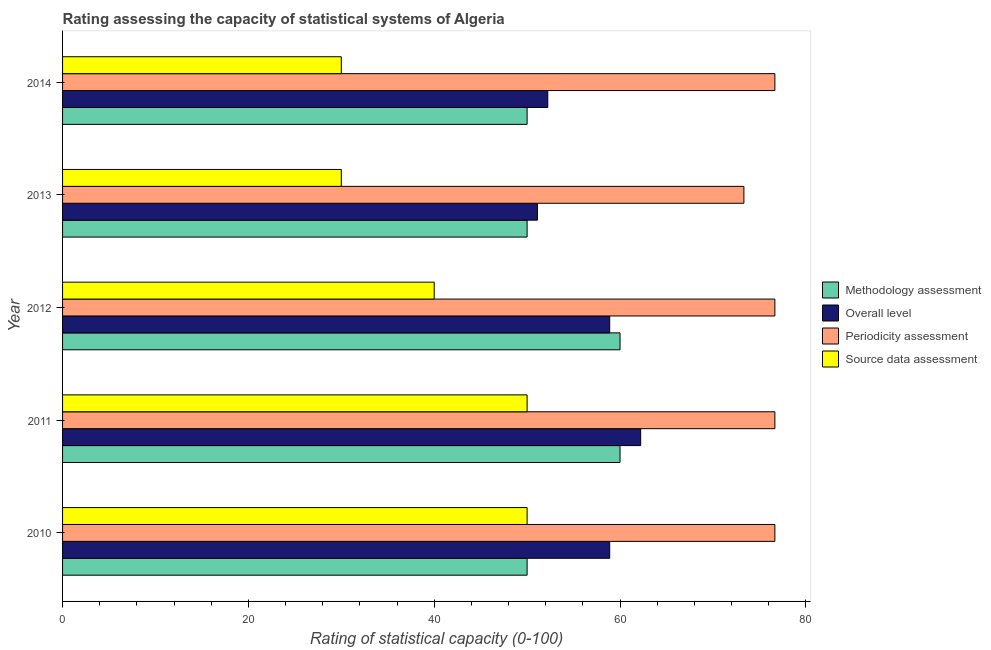How many different coloured bars are there?
Provide a short and direct response. 4. Are the number of bars on each tick of the Y-axis equal?
Offer a terse response. Yes. How many bars are there on the 3rd tick from the bottom?
Your answer should be very brief. 4. In how many cases, is the number of bars for a given year not equal to the number of legend labels?
Give a very brief answer. 0. What is the source data assessment rating in 2010?
Your answer should be compact. 50. Across all years, what is the maximum source data assessment rating?
Ensure brevity in your answer.  50. Across all years, what is the minimum overall level rating?
Provide a short and direct response. 51.11. In which year was the periodicity assessment rating maximum?
Make the answer very short. 2010. In which year was the periodicity assessment rating minimum?
Offer a terse response. 2013. What is the total methodology assessment rating in the graph?
Your response must be concise. 270. What is the difference between the overall level rating in 2010 and that in 2014?
Make the answer very short. 6.67. What is the difference between the overall level rating in 2010 and the source data assessment rating in 2014?
Keep it short and to the point. 28.89. What is the average source data assessment rating per year?
Ensure brevity in your answer.  40. In the year 2010, what is the difference between the methodology assessment rating and source data assessment rating?
Provide a short and direct response. 0. In how many years, is the methodology assessment rating greater than 56 ?
Keep it short and to the point. 2. What is the difference between the highest and the lowest source data assessment rating?
Your answer should be compact. 20. Is it the case that in every year, the sum of the overall level rating and periodicity assessment rating is greater than the sum of source data assessment rating and methodology assessment rating?
Make the answer very short. Yes. What does the 2nd bar from the top in 2010 represents?
Your answer should be compact. Periodicity assessment. What does the 2nd bar from the bottom in 2013 represents?
Ensure brevity in your answer.  Overall level. Is it the case that in every year, the sum of the methodology assessment rating and overall level rating is greater than the periodicity assessment rating?
Your answer should be very brief. Yes. How many bars are there?
Provide a short and direct response. 20. What is the difference between two consecutive major ticks on the X-axis?
Your answer should be compact. 20. Does the graph contain any zero values?
Provide a short and direct response. No. Does the graph contain grids?
Provide a succinct answer. No. How many legend labels are there?
Give a very brief answer. 4. What is the title of the graph?
Your answer should be very brief. Rating assessing the capacity of statistical systems of Algeria. Does "UNRWA" appear as one of the legend labels in the graph?
Make the answer very short. No. What is the label or title of the X-axis?
Make the answer very short. Rating of statistical capacity (0-100). What is the Rating of statistical capacity (0-100) in Overall level in 2010?
Ensure brevity in your answer.  58.89. What is the Rating of statistical capacity (0-100) in Periodicity assessment in 2010?
Give a very brief answer. 76.67. What is the Rating of statistical capacity (0-100) of Methodology assessment in 2011?
Keep it short and to the point. 60. What is the Rating of statistical capacity (0-100) in Overall level in 2011?
Ensure brevity in your answer.  62.22. What is the Rating of statistical capacity (0-100) of Periodicity assessment in 2011?
Offer a very short reply. 76.67. What is the Rating of statistical capacity (0-100) in Source data assessment in 2011?
Your response must be concise. 50. What is the Rating of statistical capacity (0-100) of Overall level in 2012?
Offer a very short reply. 58.89. What is the Rating of statistical capacity (0-100) in Periodicity assessment in 2012?
Your response must be concise. 76.67. What is the Rating of statistical capacity (0-100) of Source data assessment in 2012?
Your response must be concise. 40. What is the Rating of statistical capacity (0-100) in Overall level in 2013?
Your response must be concise. 51.11. What is the Rating of statistical capacity (0-100) of Periodicity assessment in 2013?
Provide a short and direct response. 73.33. What is the Rating of statistical capacity (0-100) in Overall level in 2014?
Provide a succinct answer. 52.22. What is the Rating of statistical capacity (0-100) in Periodicity assessment in 2014?
Provide a succinct answer. 76.67. Across all years, what is the maximum Rating of statistical capacity (0-100) in Methodology assessment?
Your answer should be very brief. 60. Across all years, what is the maximum Rating of statistical capacity (0-100) of Overall level?
Ensure brevity in your answer.  62.22. Across all years, what is the maximum Rating of statistical capacity (0-100) in Periodicity assessment?
Make the answer very short. 76.67. Across all years, what is the minimum Rating of statistical capacity (0-100) of Overall level?
Ensure brevity in your answer.  51.11. Across all years, what is the minimum Rating of statistical capacity (0-100) of Periodicity assessment?
Your answer should be very brief. 73.33. Across all years, what is the minimum Rating of statistical capacity (0-100) of Source data assessment?
Provide a succinct answer. 30. What is the total Rating of statistical capacity (0-100) of Methodology assessment in the graph?
Give a very brief answer. 270. What is the total Rating of statistical capacity (0-100) in Overall level in the graph?
Keep it short and to the point. 283.33. What is the total Rating of statistical capacity (0-100) of Periodicity assessment in the graph?
Provide a succinct answer. 380. What is the difference between the Rating of statistical capacity (0-100) in Methodology assessment in 2010 and that in 2011?
Keep it short and to the point. -10. What is the difference between the Rating of statistical capacity (0-100) of Overall level in 2010 and that in 2012?
Provide a succinct answer. 0. What is the difference between the Rating of statistical capacity (0-100) in Periodicity assessment in 2010 and that in 2012?
Keep it short and to the point. 0. What is the difference between the Rating of statistical capacity (0-100) of Methodology assessment in 2010 and that in 2013?
Your answer should be very brief. 0. What is the difference between the Rating of statistical capacity (0-100) of Overall level in 2010 and that in 2013?
Provide a short and direct response. 7.78. What is the difference between the Rating of statistical capacity (0-100) of Periodicity assessment in 2010 and that in 2013?
Your answer should be compact. 3.33. What is the difference between the Rating of statistical capacity (0-100) of Source data assessment in 2010 and that in 2013?
Provide a short and direct response. 20. What is the difference between the Rating of statistical capacity (0-100) in Periodicity assessment in 2010 and that in 2014?
Make the answer very short. 0. What is the difference between the Rating of statistical capacity (0-100) of Source data assessment in 2010 and that in 2014?
Your answer should be compact. 20. What is the difference between the Rating of statistical capacity (0-100) in Overall level in 2011 and that in 2012?
Offer a very short reply. 3.33. What is the difference between the Rating of statistical capacity (0-100) of Periodicity assessment in 2011 and that in 2012?
Your answer should be compact. 0. What is the difference between the Rating of statistical capacity (0-100) in Overall level in 2011 and that in 2013?
Your response must be concise. 11.11. What is the difference between the Rating of statistical capacity (0-100) of Periodicity assessment in 2011 and that in 2014?
Offer a very short reply. 0. What is the difference between the Rating of statistical capacity (0-100) of Methodology assessment in 2012 and that in 2013?
Offer a terse response. 10. What is the difference between the Rating of statistical capacity (0-100) of Overall level in 2012 and that in 2013?
Make the answer very short. 7.78. What is the difference between the Rating of statistical capacity (0-100) in Overall level in 2012 and that in 2014?
Your answer should be compact. 6.67. What is the difference between the Rating of statistical capacity (0-100) in Periodicity assessment in 2012 and that in 2014?
Provide a short and direct response. 0. What is the difference between the Rating of statistical capacity (0-100) of Overall level in 2013 and that in 2014?
Provide a short and direct response. -1.11. What is the difference between the Rating of statistical capacity (0-100) in Methodology assessment in 2010 and the Rating of statistical capacity (0-100) in Overall level in 2011?
Your answer should be compact. -12.22. What is the difference between the Rating of statistical capacity (0-100) of Methodology assessment in 2010 and the Rating of statistical capacity (0-100) of Periodicity assessment in 2011?
Provide a succinct answer. -26.67. What is the difference between the Rating of statistical capacity (0-100) of Methodology assessment in 2010 and the Rating of statistical capacity (0-100) of Source data assessment in 2011?
Give a very brief answer. 0. What is the difference between the Rating of statistical capacity (0-100) of Overall level in 2010 and the Rating of statistical capacity (0-100) of Periodicity assessment in 2011?
Offer a terse response. -17.78. What is the difference between the Rating of statistical capacity (0-100) in Overall level in 2010 and the Rating of statistical capacity (0-100) in Source data assessment in 2011?
Offer a terse response. 8.89. What is the difference between the Rating of statistical capacity (0-100) of Periodicity assessment in 2010 and the Rating of statistical capacity (0-100) of Source data assessment in 2011?
Provide a short and direct response. 26.67. What is the difference between the Rating of statistical capacity (0-100) in Methodology assessment in 2010 and the Rating of statistical capacity (0-100) in Overall level in 2012?
Offer a very short reply. -8.89. What is the difference between the Rating of statistical capacity (0-100) in Methodology assessment in 2010 and the Rating of statistical capacity (0-100) in Periodicity assessment in 2012?
Your answer should be compact. -26.67. What is the difference between the Rating of statistical capacity (0-100) in Methodology assessment in 2010 and the Rating of statistical capacity (0-100) in Source data assessment in 2012?
Keep it short and to the point. 10. What is the difference between the Rating of statistical capacity (0-100) of Overall level in 2010 and the Rating of statistical capacity (0-100) of Periodicity assessment in 2012?
Provide a short and direct response. -17.78. What is the difference between the Rating of statistical capacity (0-100) in Overall level in 2010 and the Rating of statistical capacity (0-100) in Source data assessment in 2012?
Keep it short and to the point. 18.89. What is the difference between the Rating of statistical capacity (0-100) in Periodicity assessment in 2010 and the Rating of statistical capacity (0-100) in Source data assessment in 2012?
Your answer should be very brief. 36.67. What is the difference between the Rating of statistical capacity (0-100) in Methodology assessment in 2010 and the Rating of statistical capacity (0-100) in Overall level in 2013?
Your response must be concise. -1.11. What is the difference between the Rating of statistical capacity (0-100) in Methodology assessment in 2010 and the Rating of statistical capacity (0-100) in Periodicity assessment in 2013?
Make the answer very short. -23.33. What is the difference between the Rating of statistical capacity (0-100) of Methodology assessment in 2010 and the Rating of statistical capacity (0-100) of Source data assessment in 2013?
Your answer should be compact. 20. What is the difference between the Rating of statistical capacity (0-100) in Overall level in 2010 and the Rating of statistical capacity (0-100) in Periodicity assessment in 2013?
Your response must be concise. -14.44. What is the difference between the Rating of statistical capacity (0-100) in Overall level in 2010 and the Rating of statistical capacity (0-100) in Source data assessment in 2013?
Provide a short and direct response. 28.89. What is the difference between the Rating of statistical capacity (0-100) of Periodicity assessment in 2010 and the Rating of statistical capacity (0-100) of Source data assessment in 2013?
Provide a short and direct response. 46.67. What is the difference between the Rating of statistical capacity (0-100) of Methodology assessment in 2010 and the Rating of statistical capacity (0-100) of Overall level in 2014?
Your answer should be very brief. -2.22. What is the difference between the Rating of statistical capacity (0-100) of Methodology assessment in 2010 and the Rating of statistical capacity (0-100) of Periodicity assessment in 2014?
Offer a terse response. -26.67. What is the difference between the Rating of statistical capacity (0-100) of Methodology assessment in 2010 and the Rating of statistical capacity (0-100) of Source data assessment in 2014?
Provide a succinct answer. 20. What is the difference between the Rating of statistical capacity (0-100) in Overall level in 2010 and the Rating of statistical capacity (0-100) in Periodicity assessment in 2014?
Give a very brief answer. -17.78. What is the difference between the Rating of statistical capacity (0-100) of Overall level in 2010 and the Rating of statistical capacity (0-100) of Source data assessment in 2014?
Your answer should be very brief. 28.89. What is the difference between the Rating of statistical capacity (0-100) of Periodicity assessment in 2010 and the Rating of statistical capacity (0-100) of Source data assessment in 2014?
Offer a terse response. 46.67. What is the difference between the Rating of statistical capacity (0-100) of Methodology assessment in 2011 and the Rating of statistical capacity (0-100) of Overall level in 2012?
Make the answer very short. 1.11. What is the difference between the Rating of statistical capacity (0-100) of Methodology assessment in 2011 and the Rating of statistical capacity (0-100) of Periodicity assessment in 2012?
Give a very brief answer. -16.67. What is the difference between the Rating of statistical capacity (0-100) in Methodology assessment in 2011 and the Rating of statistical capacity (0-100) in Source data assessment in 2012?
Ensure brevity in your answer.  20. What is the difference between the Rating of statistical capacity (0-100) in Overall level in 2011 and the Rating of statistical capacity (0-100) in Periodicity assessment in 2012?
Provide a succinct answer. -14.44. What is the difference between the Rating of statistical capacity (0-100) of Overall level in 2011 and the Rating of statistical capacity (0-100) of Source data assessment in 2012?
Your answer should be very brief. 22.22. What is the difference between the Rating of statistical capacity (0-100) of Periodicity assessment in 2011 and the Rating of statistical capacity (0-100) of Source data assessment in 2012?
Give a very brief answer. 36.67. What is the difference between the Rating of statistical capacity (0-100) of Methodology assessment in 2011 and the Rating of statistical capacity (0-100) of Overall level in 2013?
Your response must be concise. 8.89. What is the difference between the Rating of statistical capacity (0-100) of Methodology assessment in 2011 and the Rating of statistical capacity (0-100) of Periodicity assessment in 2013?
Offer a terse response. -13.33. What is the difference between the Rating of statistical capacity (0-100) of Methodology assessment in 2011 and the Rating of statistical capacity (0-100) of Source data assessment in 2013?
Ensure brevity in your answer.  30. What is the difference between the Rating of statistical capacity (0-100) of Overall level in 2011 and the Rating of statistical capacity (0-100) of Periodicity assessment in 2013?
Make the answer very short. -11.11. What is the difference between the Rating of statistical capacity (0-100) of Overall level in 2011 and the Rating of statistical capacity (0-100) of Source data assessment in 2013?
Ensure brevity in your answer.  32.22. What is the difference between the Rating of statistical capacity (0-100) of Periodicity assessment in 2011 and the Rating of statistical capacity (0-100) of Source data assessment in 2013?
Your response must be concise. 46.67. What is the difference between the Rating of statistical capacity (0-100) in Methodology assessment in 2011 and the Rating of statistical capacity (0-100) in Overall level in 2014?
Offer a very short reply. 7.78. What is the difference between the Rating of statistical capacity (0-100) of Methodology assessment in 2011 and the Rating of statistical capacity (0-100) of Periodicity assessment in 2014?
Provide a short and direct response. -16.67. What is the difference between the Rating of statistical capacity (0-100) in Methodology assessment in 2011 and the Rating of statistical capacity (0-100) in Source data assessment in 2014?
Offer a very short reply. 30. What is the difference between the Rating of statistical capacity (0-100) of Overall level in 2011 and the Rating of statistical capacity (0-100) of Periodicity assessment in 2014?
Ensure brevity in your answer.  -14.44. What is the difference between the Rating of statistical capacity (0-100) of Overall level in 2011 and the Rating of statistical capacity (0-100) of Source data assessment in 2014?
Your answer should be compact. 32.22. What is the difference between the Rating of statistical capacity (0-100) in Periodicity assessment in 2011 and the Rating of statistical capacity (0-100) in Source data assessment in 2014?
Your response must be concise. 46.67. What is the difference between the Rating of statistical capacity (0-100) of Methodology assessment in 2012 and the Rating of statistical capacity (0-100) of Overall level in 2013?
Provide a short and direct response. 8.89. What is the difference between the Rating of statistical capacity (0-100) of Methodology assessment in 2012 and the Rating of statistical capacity (0-100) of Periodicity assessment in 2013?
Provide a short and direct response. -13.33. What is the difference between the Rating of statistical capacity (0-100) of Overall level in 2012 and the Rating of statistical capacity (0-100) of Periodicity assessment in 2013?
Provide a succinct answer. -14.44. What is the difference between the Rating of statistical capacity (0-100) in Overall level in 2012 and the Rating of statistical capacity (0-100) in Source data assessment in 2013?
Provide a short and direct response. 28.89. What is the difference between the Rating of statistical capacity (0-100) in Periodicity assessment in 2012 and the Rating of statistical capacity (0-100) in Source data assessment in 2013?
Make the answer very short. 46.67. What is the difference between the Rating of statistical capacity (0-100) of Methodology assessment in 2012 and the Rating of statistical capacity (0-100) of Overall level in 2014?
Give a very brief answer. 7.78. What is the difference between the Rating of statistical capacity (0-100) in Methodology assessment in 2012 and the Rating of statistical capacity (0-100) in Periodicity assessment in 2014?
Your response must be concise. -16.67. What is the difference between the Rating of statistical capacity (0-100) in Methodology assessment in 2012 and the Rating of statistical capacity (0-100) in Source data assessment in 2014?
Provide a succinct answer. 30. What is the difference between the Rating of statistical capacity (0-100) in Overall level in 2012 and the Rating of statistical capacity (0-100) in Periodicity assessment in 2014?
Your answer should be very brief. -17.78. What is the difference between the Rating of statistical capacity (0-100) of Overall level in 2012 and the Rating of statistical capacity (0-100) of Source data assessment in 2014?
Give a very brief answer. 28.89. What is the difference between the Rating of statistical capacity (0-100) of Periodicity assessment in 2012 and the Rating of statistical capacity (0-100) of Source data assessment in 2014?
Ensure brevity in your answer.  46.67. What is the difference between the Rating of statistical capacity (0-100) of Methodology assessment in 2013 and the Rating of statistical capacity (0-100) of Overall level in 2014?
Your answer should be very brief. -2.22. What is the difference between the Rating of statistical capacity (0-100) of Methodology assessment in 2013 and the Rating of statistical capacity (0-100) of Periodicity assessment in 2014?
Provide a succinct answer. -26.67. What is the difference between the Rating of statistical capacity (0-100) in Overall level in 2013 and the Rating of statistical capacity (0-100) in Periodicity assessment in 2014?
Ensure brevity in your answer.  -25.56. What is the difference between the Rating of statistical capacity (0-100) of Overall level in 2013 and the Rating of statistical capacity (0-100) of Source data assessment in 2014?
Make the answer very short. 21.11. What is the difference between the Rating of statistical capacity (0-100) of Periodicity assessment in 2013 and the Rating of statistical capacity (0-100) of Source data assessment in 2014?
Provide a short and direct response. 43.33. What is the average Rating of statistical capacity (0-100) in Methodology assessment per year?
Your answer should be very brief. 54. What is the average Rating of statistical capacity (0-100) in Overall level per year?
Make the answer very short. 56.67. What is the average Rating of statistical capacity (0-100) in Periodicity assessment per year?
Give a very brief answer. 76. In the year 2010, what is the difference between the Rating of statistical capacity (0-100) in Methodology assessment and Rating of statistical capacity (0-100) in Overall level?
Your answer should be compact. -8.89. In the year 2010, what is the difference between the Rating of statistical capacity (0-100) in Methodology assessment and Rating of statistical capacity (0-100) in Periodicity assessment?
Your answer should be very brief. -26.67. In the year 2010, what is the difference between the Rating of statistical capacity (0-100) of Methodology assessment and Rating of statistical capacity (0-100) of Source data assessment?
Your answer should be very brief. 0. In the year 2010, what is the difference between the Rating of statistical capacity (0-100) of Overall level and Rating of statistical capacity (0-100) of Periodicity assessment?
Keep it short and to the point. -17.78. In the year 2010, what is the difference between the Rating of statistical capacity (0-100) of Overall level and Rating of statistical capacity (0-100) of Source data assessment?
Make the answer very short. 8.89. In the year 2010, what is the difference between the Rating of statistical capacity (0-100) in Periodicity assessment and Rating of statistical capacity (0-100) in Source data assessment?
Provide a succinct answer. 26.67. In the year 2011, what is the difference between the Rating of statistical capacity (0-100) of Methodology assessment and Rating of statistical capacity (0-100) of Overall level?
Ensure brevity in your answer.  -2.22. In the year 2011, what is the difference between the Rating of statistical capacity (0-100) of Methodology assessment and Rating of statistical capacity (0-100) of Periodicity assessment?
Provide a short and direct response. -16.67. In the year 2011, what is the difference between the Rating of statistical capacity (0-100) in Methodology assessment and Rating of statistical capacity (0-100) in Source data assessment?
Your answer should be very brief. 10. In the year 2011, what is the difference between the Rating of statistical capacity (0-100) in Overall level and Rating of statistical capacity (0-100) in Periodicity assessment?
Your response must be concise. -14.44. In the year 2011, what is the difference between the Rating of statistical capacity (0-100) in Overall level and Rating of statistical capacity (0-100) in Source data assessment?
Offer a very short reply. 12.22. In the year 2011, what is the difference between the Rating of statistical capacity (0-100) in Periodicity assessment and Rating of statistical capacity (0-100) in Source data assessment?
Your response must be concise. 26.67. In the year 2012, what is the difference between the Rating of statistical capacity (0-100) of Methodology assessment and Rating of statistical capacity (0-100) of Periodicity assessment?
Ensure brevity in your answer.  -16.67. In the year 2012, what is the difference between the Rating of statistical capacity (0-100) in Overall level and Rating of statistical capacity (0-100) in Periodicity assessment?
Your answer should be very brief. -17.78. In the year 2012, what is the difference between the Rating of statistical capacity (0-100) in Overall level and Rating of statistical capacity (0-100) in Source data assessment?
Give a very brief answer. 18.89. In the year 2012, what is the difference between the Rating of statistical capacity (0-100) in Periodicity assessment and Rating of statistical capacity (0-100) in Source data assessment?
Offer a very short reply. 36.67. In the year 2013, what is the difference between the Rating of statistical capacity (0-100) in Methodology assessment and Rating of statistical capacity (0-100) in Overall level?
Make the answer very short. -1.11. In the year 2013, what is the difference between the Rating of statistical capacity (0-100) of Methodology assessment and Rating of statistical capacity (0-100) of Periodicity assessment?
Provide a short and direct response. -23.33. In the year 2013, what is the difference between the Rating of statistical capacity (0-100) of Overall level and Rating of statistical capacity (0-100) of Periodicity assessment?
Keep it short and to the point. -22.22. In the year 2013, what is the difference between the Rating of statistical capacity (0-100) of Overall level and Rating of statistical capacity (0-100) of Source data assessment?
Offer a terse response. 21.11. In the year 2013, what is the difference between the Rating of statistical capacity (0-100) of Periodicity assessment and Rating of statistical capacity (0-100) of Source data assessment?
Offer a very short reply. 43.33. In the year 2014, what is the difference between the Rating of statistical capacity (0-100) in Methodology assessment and Rating of statistical capacity (0-100) in Overall level?
Give a very brief answer. -2.22. In the year 2014, what is the difference between the Rating of statistical capacity (0-100) in Methodology assessment and Rating of statistical capacity (0-100) in Periodicity assessment?
Ensure brevity in your answer.  -26.67. In the year 2014, what is the difference between the Rating of statistical capacity (0-100) of Overall level and Rating of statistical capacity (0-100) of Periodicity assessment?
Offer a very short reply. -24.44. In the year 2014, what is the difference between the Rating of statistical capacity (0-100) of Overall level and Rating of statistical capacity (0-100) of Source data assessment?
Keep it short and to the point. 22.22. In the year 2014, what is the difference between the Rating of statistical capacity (0-100) of Periodicity assessment and Rating of statistical capacity (0-100) of Source data assessment?
Ensure brevity in your answer.  46.67. What is the ratio of the Rating of statistical capacity (0-100) of Methodology assessment in 2010 to that in 2011?
Provide a succinct answer. 0.83. What is the ratio of the Rating of statistical capacity (0-100) of Overall level in 2010 to that in 2011?
Your response must be concise. 0.95. What is the ratio of the Rating of statistical capacity (0-100) of Source data assessment in 2010 to that in 2011?
Make the answer very short. 1. What is the ratio of the Rating of statistical capacity (0-100) of Overall level in 2010 to that in 2012?
Offer a very short reply. 1. What is the ratio of the Rating of statistical capacity (0-100) of Periodicity assessment in 2010 to that in 2012?
Make the answer very short. 1. What is the ratio of the Rating of statistical capacity (0-100) in Source data assessment in 2010 to that in 2012?
Your answer should be very brief. 1.25. What is the ratio of the Rating of statistical capacity (0-100) of Methodology assessment in 2010 to that in 2013?
Offer a terse response. 1. What is the ratio of the Rating of statistical capacity (0-100) in Overall level in 2010 to that in 2013?
Your answer should be very brief. 1.15. What is the ratio of the Rating of statistical capacity (0-100) in Periodicity assessment in 2010 to that in 2013?
Your response must be concise. 1.05. What is the ratio of the Rating of statistical capacity (0-100) in Methodology assessment in 2010 to that in 2014?
Provide a succinct answer. 1. What is the ratio of the Rating of statistical capacity (0-100) of Overall level in 2010 to that in 2014?
Provide a succinct answer. 1.13. What is the ratio of the Rating of statistical capacity (0-100) of Source data assessment in 2010 to that in 2014?
Make the answer very short. 1.67. What is the ratio of the Rating of statistical capacity (0-100) in Methodology assessment in 2011 to that in 2012?
Your answer should be very brief. 1. What is the ratio of the Rating of statistical capacity (0-100) in Overall level in 2011 to that in 2012?
Give a very brief answer. 1.06. What is the ratio of the Rating of statistical capacity (0-100) of Source data assessment in 2011 to that in 2012?
Ensure brevity in your answer.  1.25. What is the ratio of the Rating of statistical capacity (0-100) of Methodology assessment in 2011 to that in 2013?
Ensure brevity in your answer.  1.2. What is the ratio of the Rating of statistical capacity (0-100) of Overall level in 2011 to that in 2013?
Make the answer very short. 1.22. What is the ratio of the Rating of statistical capacity (0-100) in Periodicity assessment in 2011 to that in 2013?
Provide a short and direct response. 1.05. What is the ratio of the Rating of statistical capacity (0-100) in Source data assessment in 2011 to that in 2013?
Keep it short and to the point. 1.67. What is the ratio of the Rating of statistical capacity (0-100) of Overall level in 2011 to that in 2014?
Offer a very short reply. 1.19. What is the ratio of the Rating of statistical capacity (0-100) in Periodicity assessment in 2011 to that in 2014?
Provide a succinct answer. 1. What is the ratio of the Rating of statistical capacity (0-100) of Methodology assessment in 2012 to that in 2013?
Make the answer very short. 1.2. What is the ratio of the Rating of statistical capacity (0-100) of Overall level in 2012 to that in 2013?
Keep it short and to the point. 1.15. What is the ratio of the Rating of statistical capacity (0-100) of Periodicity assessment in 2012 to that in 2013?
Provide a succinct answer. 1.05. What is the ratio of the Rating of statistical capacity (0-100) of Source data assessment in 2012 to that in 2013?
Offer a very short reply. 1.33. What is the ratio of the Rating of statistical capacity (0-100) of Overall level in 2012 to that in 2014?
Give a very brief answer. 1.13. What is the ratio of the Rating of statistical capacity (0-100) of Source data assessment in 2012 to that in 2014?
Provide a succinct answer. 1.33. What is the ratio of the Rating of statistical capacity (0-100) of Overall level in 2013 to that in 2014?
Provide a short and direct response. 0.98. What is the ratio of the Rating of statistical capacity (0-100) of Periodicity assessment in 2013 to that in 2014?
Ensure brevity in your answer.  0.96. What is the difference between the highest and the second highest Rating of statistical capacity (0-100) in Periodicity assessment?
Your response must be concise. 0. What is the difference between the highest and the second highest Rating of statistical capacity (0-100) in Source data assessment?
Offer a very short reply. 0. What is the difference between the highest and the lowest Rating of statistical capacity (0-100) in Overall level?
Ensure brevity in your answer.  11.11. 